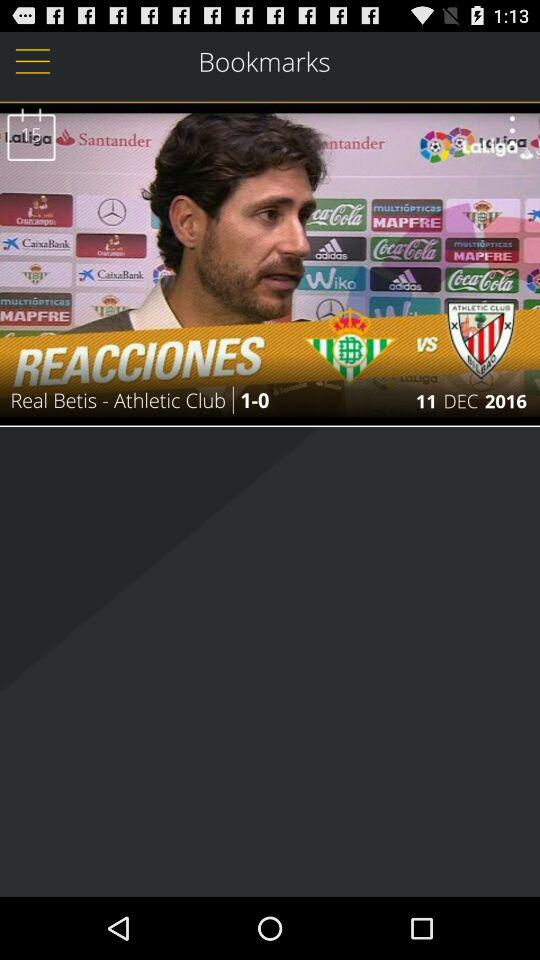What is the score? The score is 1-0. 